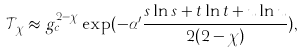Convert formula to latex. <formula><loc_0><loc_0><loc_500><loc_500>\mathcal { T } _ { \chi } \approx g _ { c } ^ { 2 - \chi } \exp ( - \alpha ^ { \prime } \frac { s \ln s + t \ln t + u \ln u } { 2 ( 2 - \chi ) } ) ,</formula> 